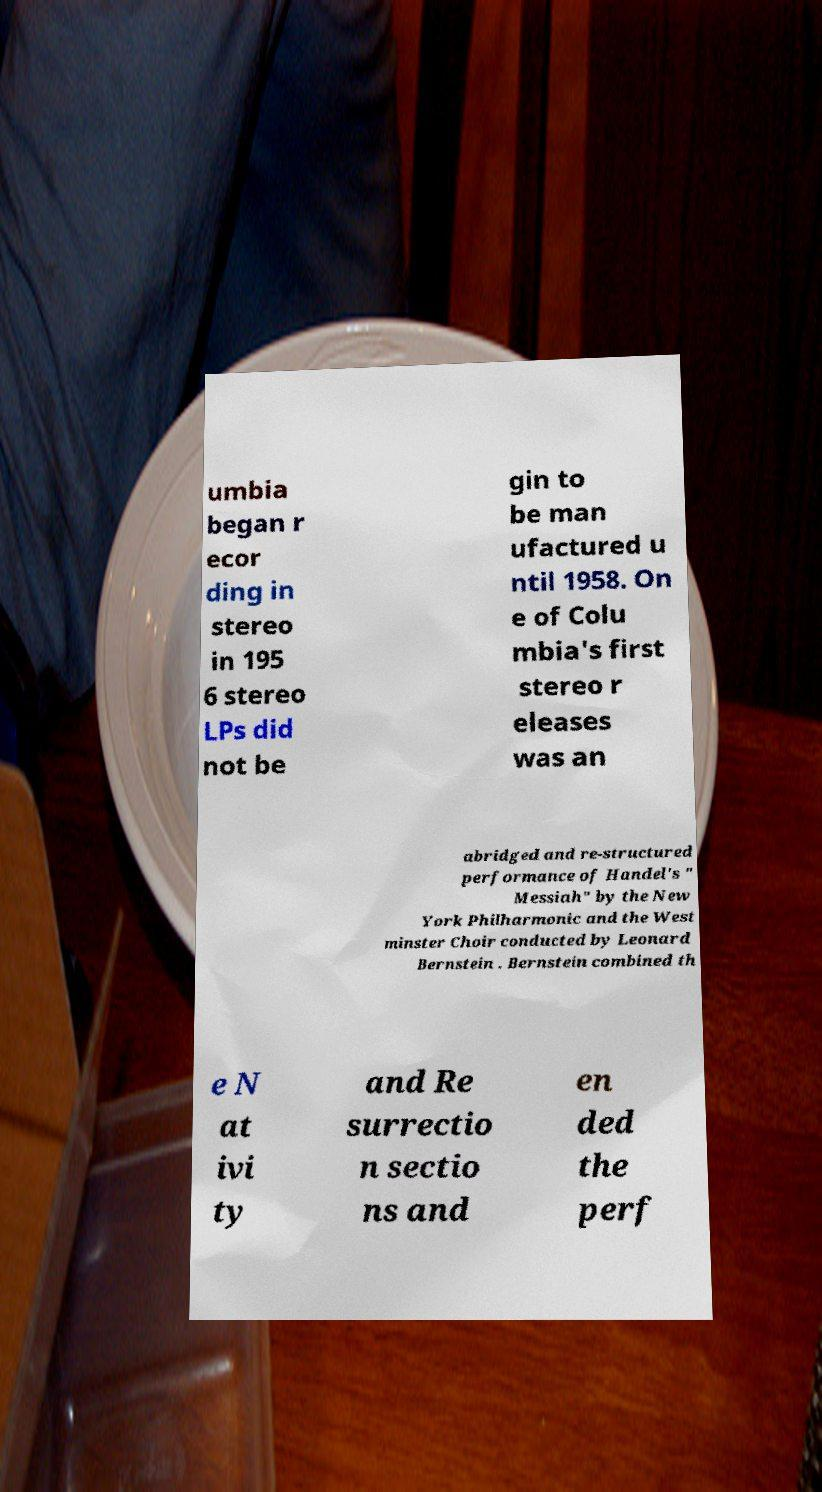Please read and relay the text visible in this image. What does it say? umbia began r ecor ding in stereo in 195 6 stereo LPs did not be gin to be man ufactured u ntil 1958. On e of Colu mbia's first stereo r eleases was an abridged and re-structured performance of Handel's " Messiah" by the New York Philharmonic and the West minster Choir conducted by Leonard Bernstein . Bernstein combined th e N at ivi ty and Re surrectio n sectio ns and en ded the perf 